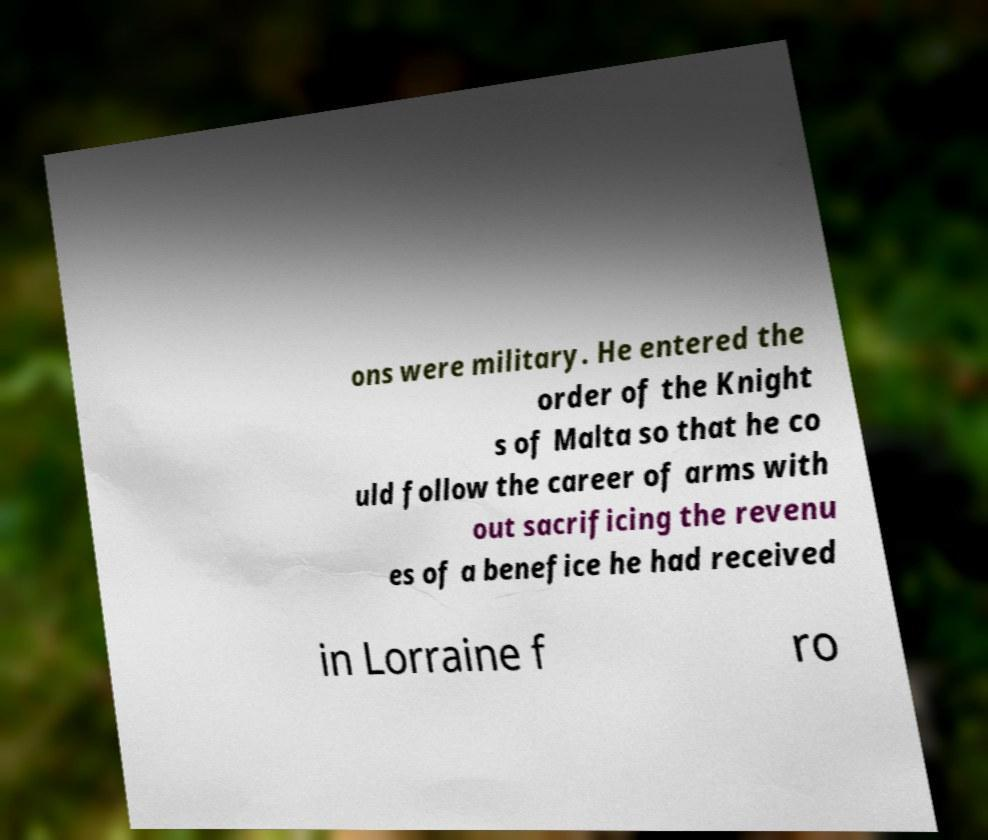Could you assist in decoding the text presented in this image and type it out clearly? ons were military. He entered the order of the Knight s of Malta so that he co uld follow the career of arms with out sacrificing the revenu es of a benefice he had received in Lorraine f ro 